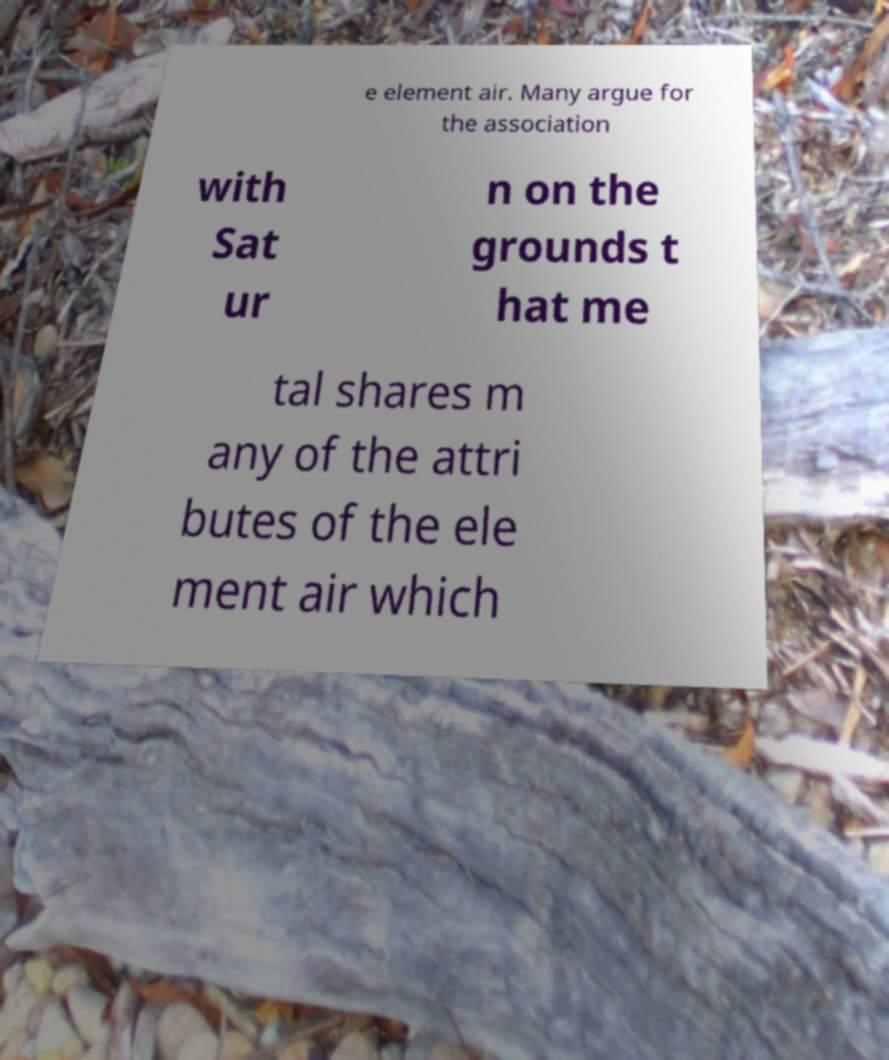Could you extract and type out the text from this image? e element air. Many argue for the association with Sat ur n on the grounds t hat me tal shares m any of the attri butes of the ele ment air which 